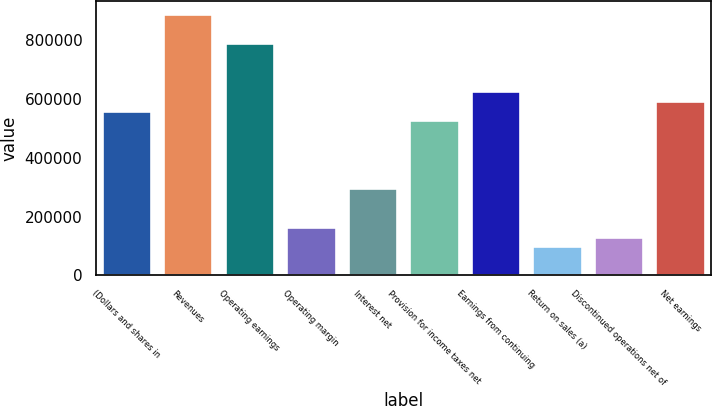<chart> <loc_0><loc_0><loc_500><loc_500><bar_chart><fcel>(Dollars and shares in<fcel>Revenues<fcel>Operating earnings<fcel>Operating margin<fcel>Interest net<fcel>Provision for income taxes net<fcel>Earnings from continuing<fcel>Return on sales (a)<fcel>Discontinued operations net of<fcel>Net earnings<nl><fcel>559979<fcel>889378<fcel>790558<fcel>164701<fcel>296460<fcel>527039<fcel>625859<fcel>98820.8<fcel>131761<fcel>592919<nl></chart> 